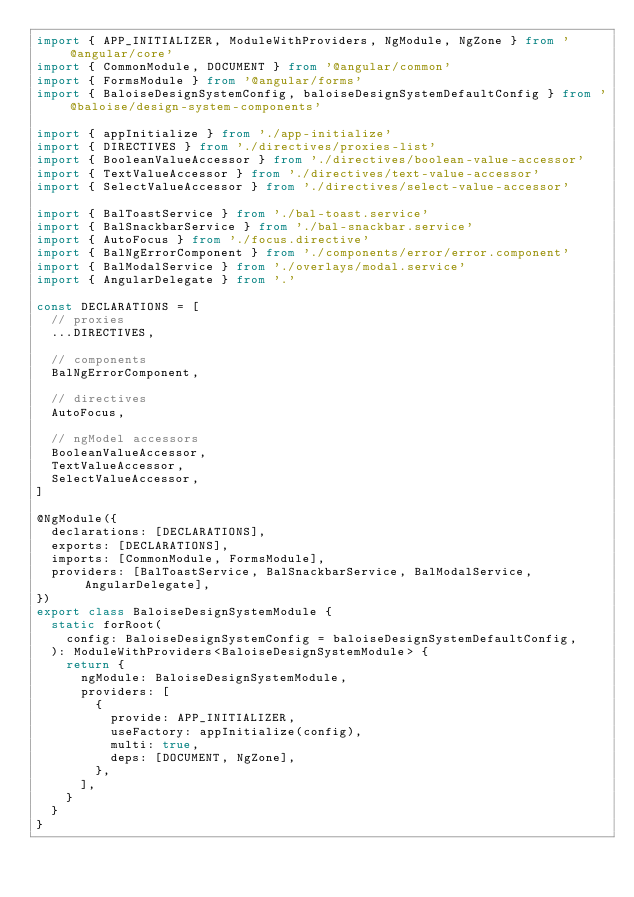Convert code to text. <code><loc_0><loc_0><loc_500><loc_500><_TypeScript_>import { APP_INITIALIZER, ModuleWithProviders, NgModule, NgZone } from '@angular/core'
import { CommonModule, DOCUMENT } from '@angular/common'
import { FormsModule } from '@angular/forms'
import { BaloiseDesignSystemConfig, baloiseDesignSystemDefaultConfig } from '@baloise/design-system-components'

import { appInitialize } from './app-initialize'
import { DIRECTIVES } from './directives/proxies-list'
import { BooleanValueAccessor } from './directives/boolean-value-accessor'
import { TextValueAccessor } from './directives/text-value-accessor'
import { SelectValueAccessor } from './directives/select-value-accessor'

import { BalToastService } from './bal-toast.service'
import { BalSnackbarService } from './bal-snackbar.service'
import { AutoFocus } from './focus.directive'
import { BalNgErrorComponent } from './components/error/error.component'
import { BalModalService } from './overlays/modal.service'
import { AngularDelegate } from '.'

const DECLARATIONS = [
  // proxies
  ...DIRECTIVES,

  // components
  BalNgErrorComponent,

  // directives
  AutoFocus,

  // ngModel accessors
  BooleanValueAccessor,
  TextValueAccessor,
  SelectValueAccessor,
]

@NgModule({
  declarations: [DECLARATIONS],
  exports: [DECLARATIONS],
  imports: [CommonModule, FormsModule],
  providers: [BalToastService, BalSnackbarService, BalModalService, AngularDelegate],
})
export class BaloiseDesignSystemModule {
  static forRoot(
    config: BaloiseDesignSystemConfig = baloiseDesignSystemDefaultConfig,
  ): ModuleWithProviders<BaloiseDesignSystemModule> {
    return {
      ngModule: BaloiseDesignSystemModule,
      providers: [
        {
          provide: APP_INITIALIZER,
          useFactory: appInitialize(config),
          multi: true,
          deps: [DOCUMENT, NgZone],
        },
      ],
    }
  }
}
</code> 